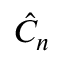<formula> <loc_0><loc_0><loc_500><loc_500>\hat { C } _ { n }</formula> 